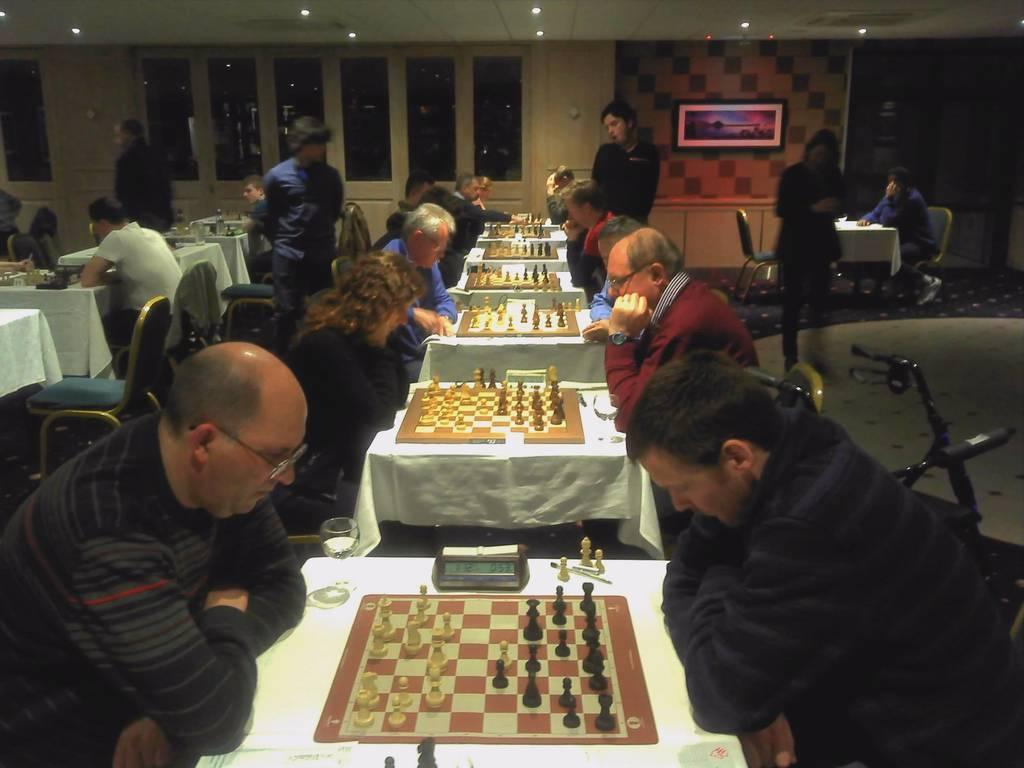What are the people in the image doing? The people in the image are playing chess. How are the people playing chess positioned in relation to each other? The people are sitting in front of each other in the image. Are there any spectators in the image? Yes, some people are watching the chess games. What can be seen in the background of the image? There is a photograph attached to the wall in the background. What type of tax is being discussed by the people playing chess in the image? There is no discussion of taxes in the image; the people are focused on playing chess. What musical instrument is being played by the people in the image? There is no musical instrument being played in the image; the people are playing chess. 